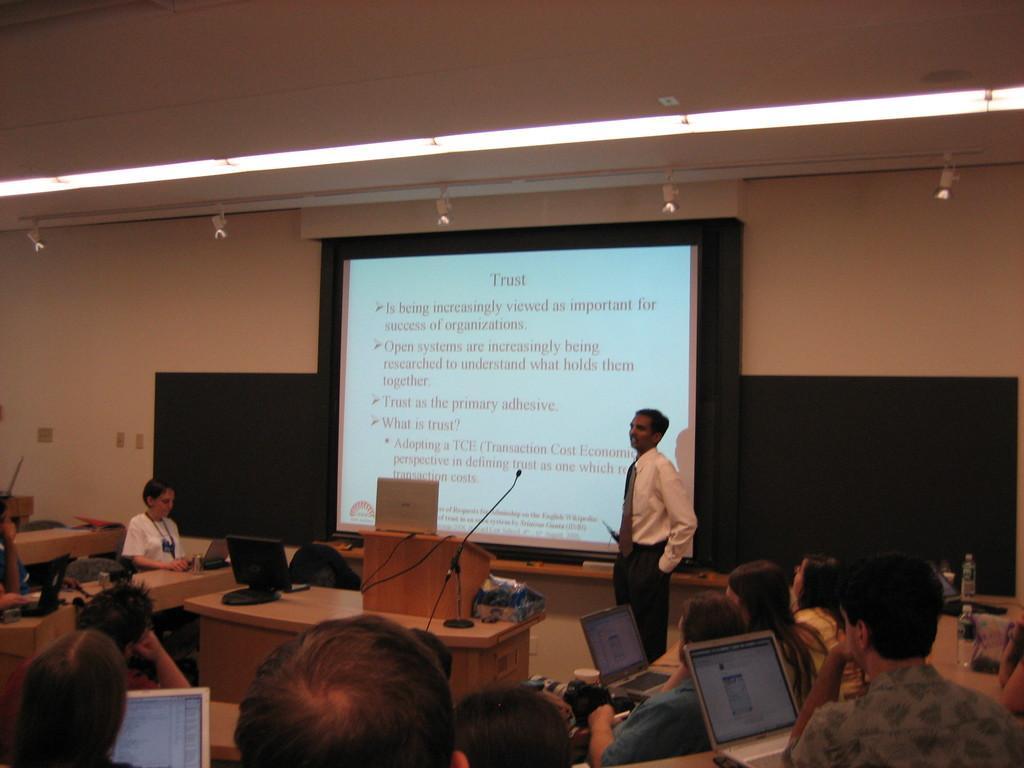Describe this image in one or two sentences. This picture describes about group of people, few are seated and a man is standing, in front of them we can find laptops, in the background we can see a projector screen, microphone and few bottles on the tables, and also we can find few lights. 